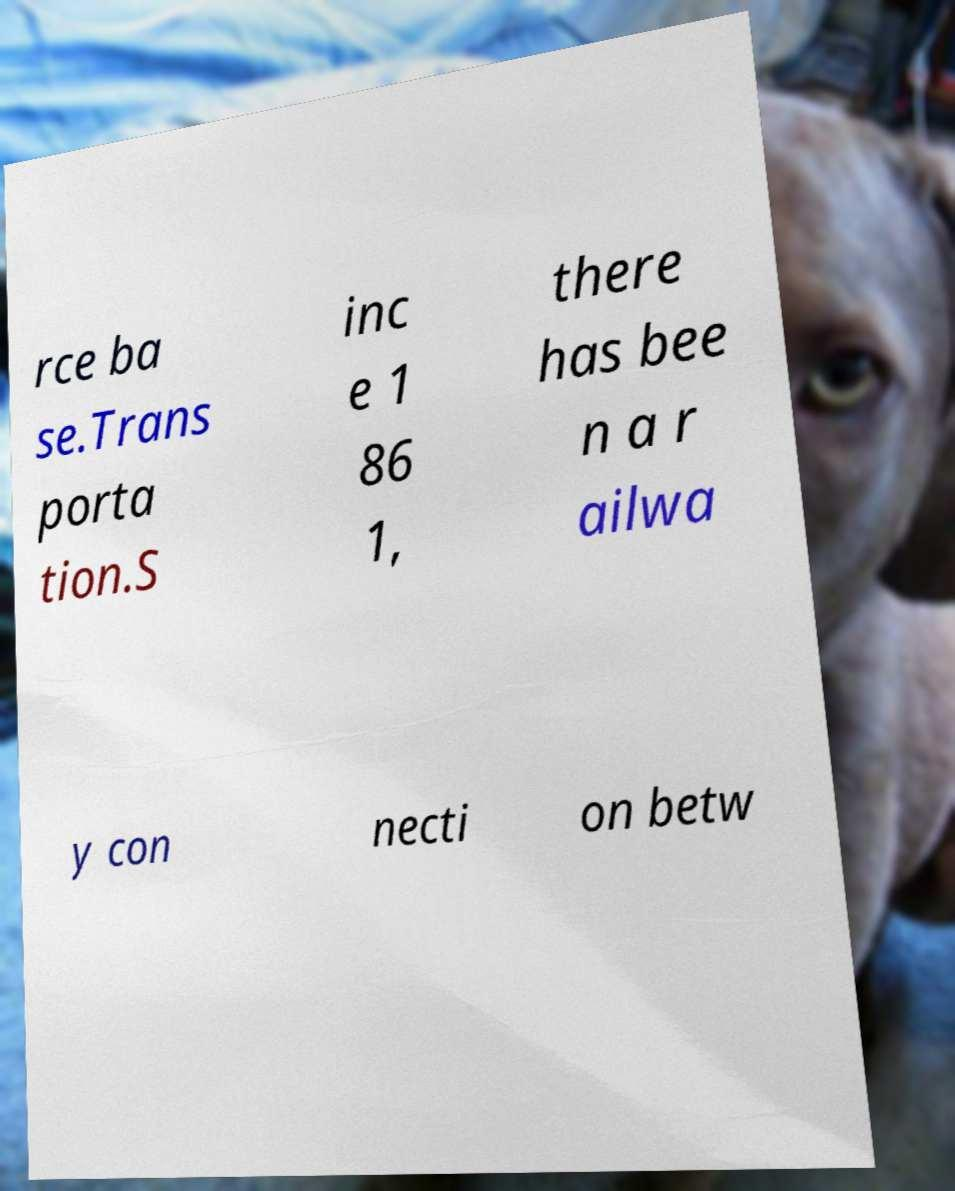Could you extract and type out the text from this image? rce ba se.Trans porta tion.S inc e 1 86 1, there has bee n a r ailwa y con necti on betw 